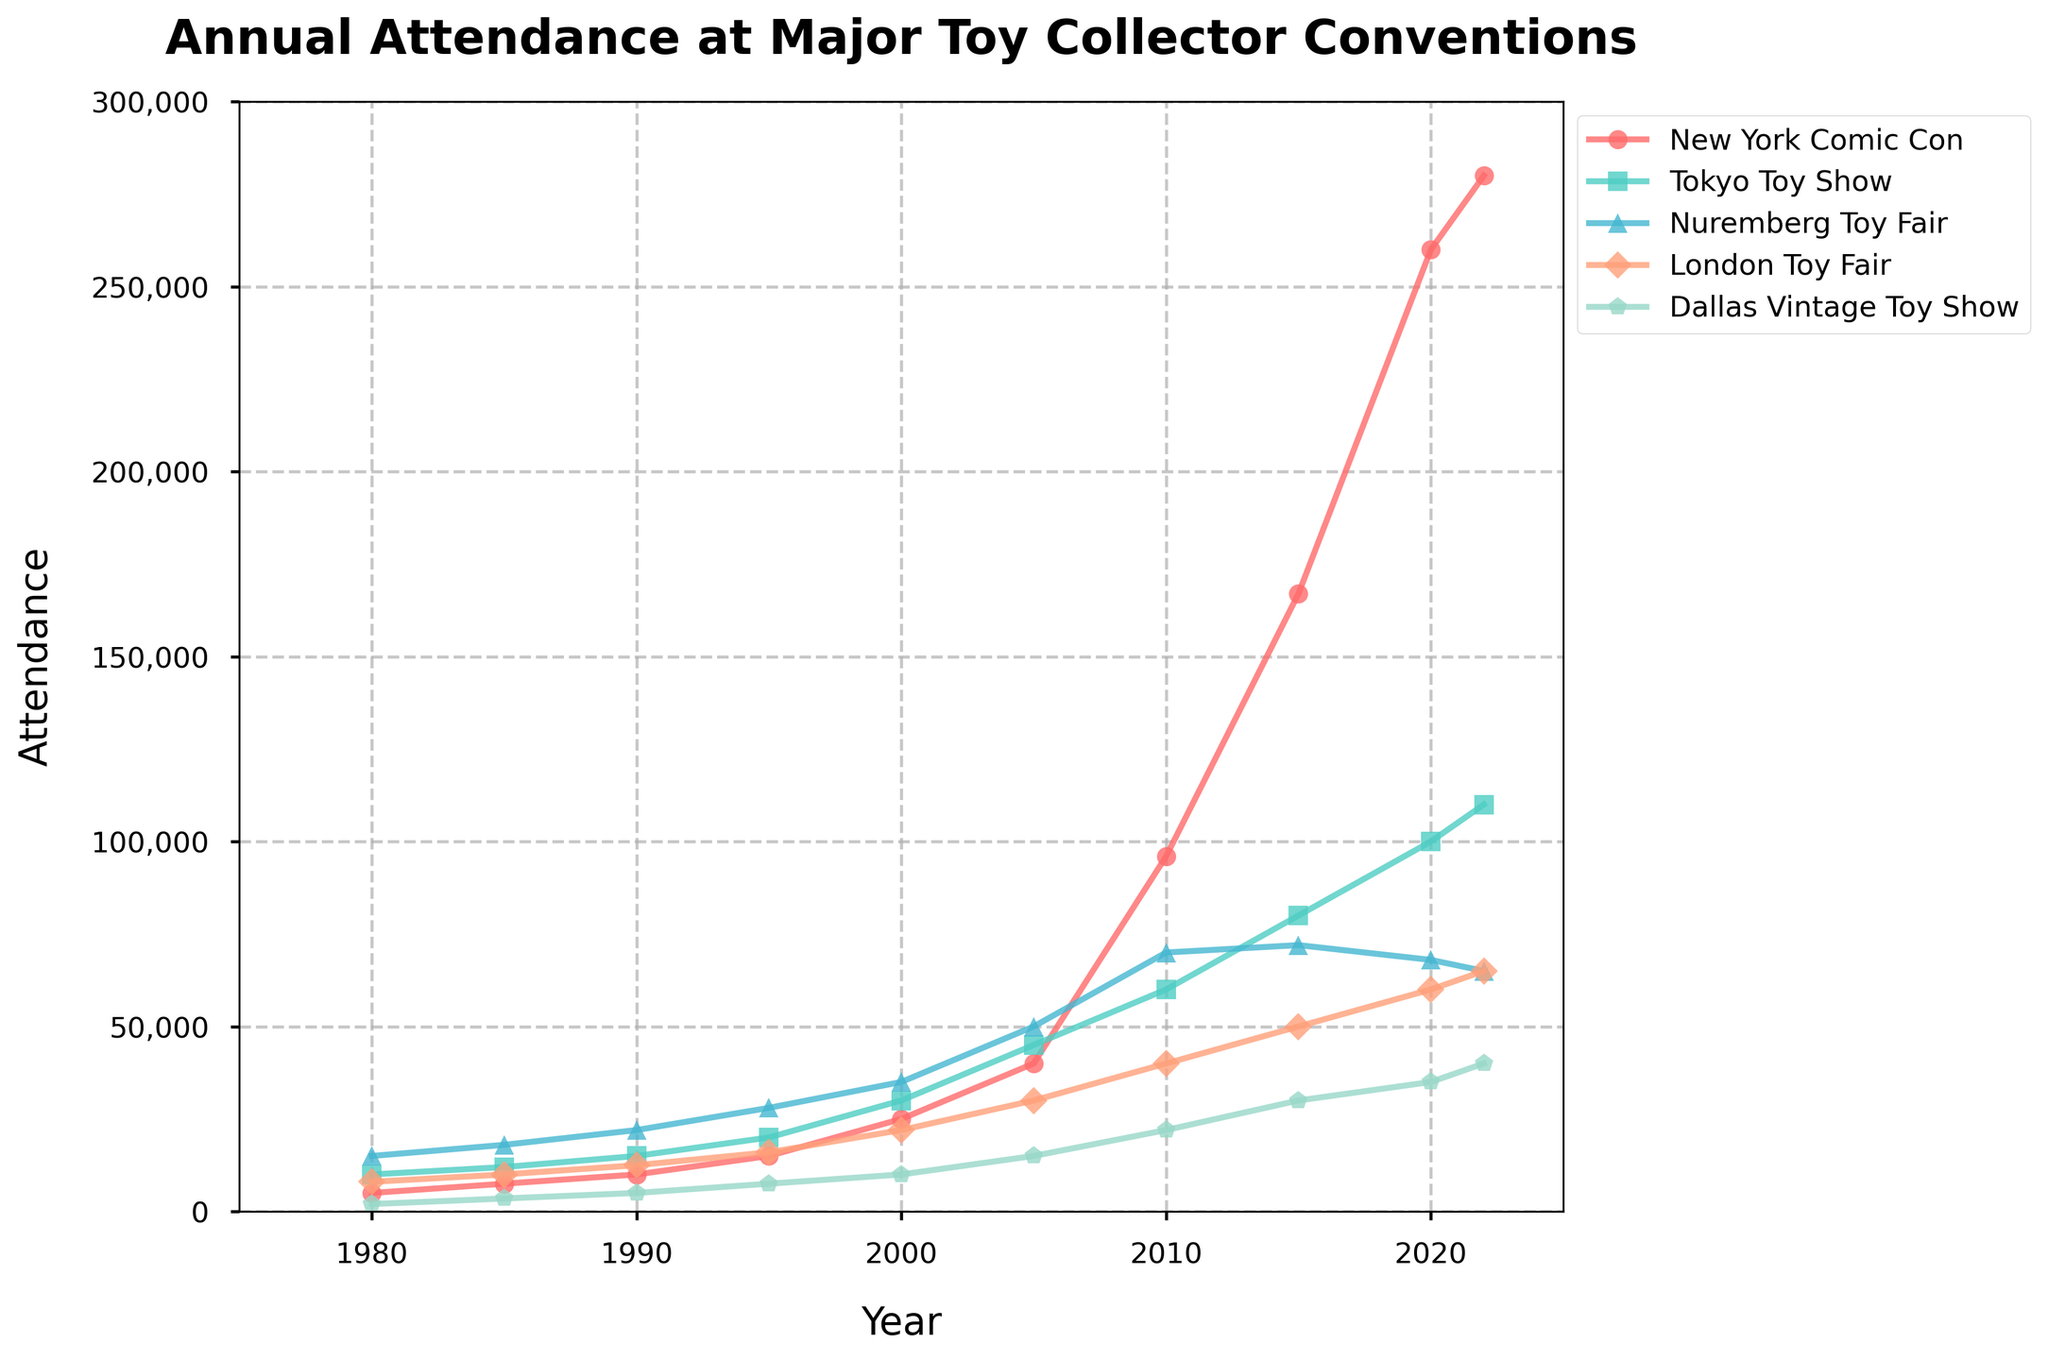What is the total increase in attendance for the New York Comic Con from 1980 to 2022? In 1980, the attendance for the New York Comic Con was 5,000, and in 2022, it was 280,000. The increase is 280,000 - 5,000 = 275,000.
Answer: 275,000 Which convention had the highest attendance in 2022? By looking at the 2022 data points, the New York Comic Con has the highest attendance of 280,000.
Answer: New York Comic Con How does the attendance at the Tokyo Toy Show in 2010 compare to the London Toy Fair in the same year? In 2010, the attendance for the Tokyo Toy Show was 60,000, while the London Toy Fair had 40,000. Hence, the Tokyo Toy Show had 20,000 more attendees than the London Toy Fair in 2010.
Answer: 20,000 more attendees for Tokyo Toy Show Between which years did the Dallas Vintage Toy Show see the greatest increase in attendance? Checking the differences between adjacent years for the Dallas Vintage Toy Show: 
From 1980 to 1985: 3,500 - 2,000 = 1,500;
From 1985 to 1990: 5,000 - 3,500 = 1,500;
From 1990 to 1995: 7,500 - 5,000 = 2,500;
From 1995 to 2000: 10,000 - 7,500 = 2,500;
From 2000 to 2005: 15,000 - 10,000 = 5,000;
From 2005 to 2010: 22,000 - 15,000 = 7,000;
From 2010 to 2015: 30,000 - 22,000 = 8,000;
From 2015 to 2020: 35,000 - 30,000 = 5,000;
From 2020 to 2022: 40,000 - 35,000 = 5,000;
The greatest increase was from 2010 to 2015.
Answer: 2010 to 2015 What is the average attendance at the Nuremberg Toy Fair across all given years? Summing the attendance figures for the Nuremberg Toy Fair from each year: 15,000 + 18,000 + 22,000 + 28,000 + 35,000 + 50,000 + 70,000 + 72,000 + 68,000 + 65,000 = 443,000. Then, divide by the number of years (10): 443,000 / 10 = 44,300.
Answer: 44,300 Which convention had the smallest attendance increase from 2015 to 2020? Looking at the differences in attendance from 2015 to 2020:
New York Comic Con: 260,000 - 167,000 = 93,000;
Tokyo Toy Show: 100,000 - 80,000 = 20,000;
Nuremberg Toy Fair: 68,000 - 72,000 = -4,000 (a decrease);
London Toy Fair: 60,000 - 50,000 = 10,000;
Dallas Vintage Toy Show: 35,000 - 30,000 = 5,000.
Thus, the Nuremberg Toy Fair actually saw a decrease (the smallest).
Answer: Nuremberg Toy Fair Comparing the attendance of the New York Comic Con and the Dallas Vintage Toy Show in 2005, how much greater was the attendance at the New York Comic Con? In 2005, the attendance at the New York Comic Con was 40,000, while the Dallas Vintage Toy Show had 15,000 attendees. The difference is 40,000 - 15,000 = 25,000.
Answer: 25,000 more attendees for New York Comic Con Which convention shows the most consistent increase in attendance across the years? By observing the trends in the data, the New York Comic Con shows the most consistent increase in its attendance figures across the given years without any drops.
Answer: New York Comic Con In which year did the London Toy Fair have exactly half the attendance of the New York Comic Con? In 1995, the London Toy Fair had an attendance of 16,000, and the New York Comic Con had an attendance of 30,000. This fits the condition as 16,000 is approximately half of 30,000.
Answer: 1995 